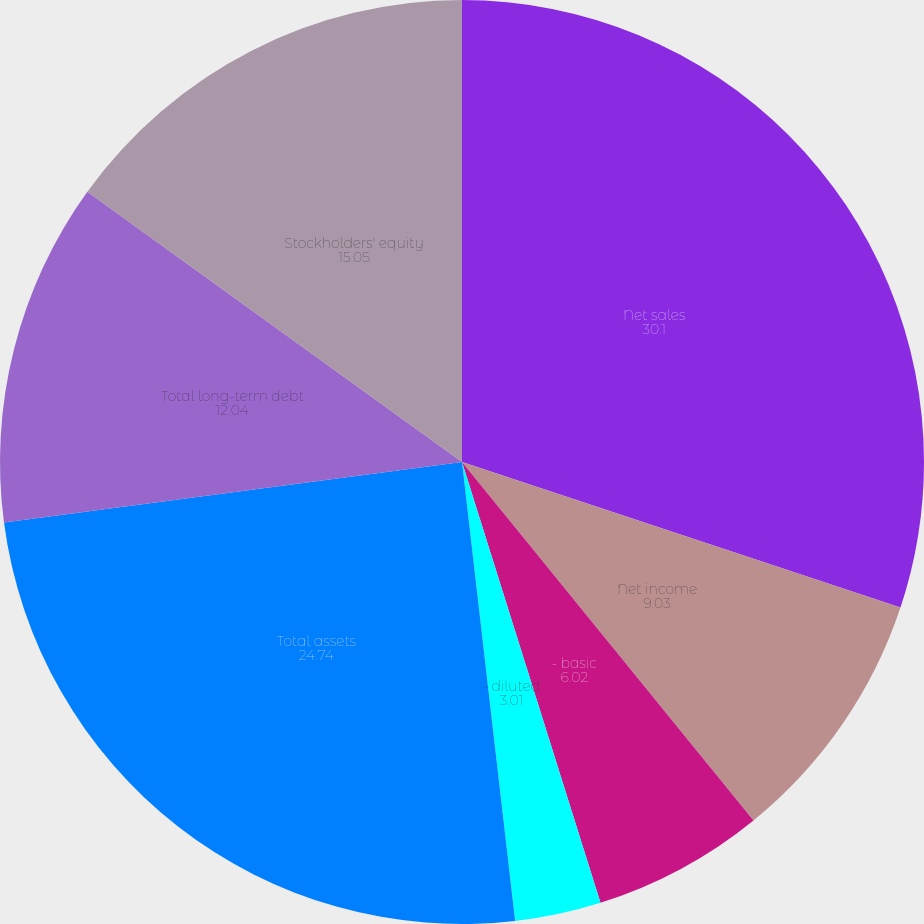Convert chart. <chart><loc_0><loc_0><loc_500><loc_500><pie_chart><fcel>Net sales<fcel>Net income<fcel>- basic<fcel>- diluted<fcel>Cash dividends declared per<fcel>Total assets<fcel>Total long-term debt<fcel>Stockholders' equity<nl><fcel>30.1%<fcel>9.03%<fcel>6.02%<fcel>3.01%<fcel>0.0%<fcel>24.74%<fcel>12.04%<fcel>15.05%<nl></chart> 